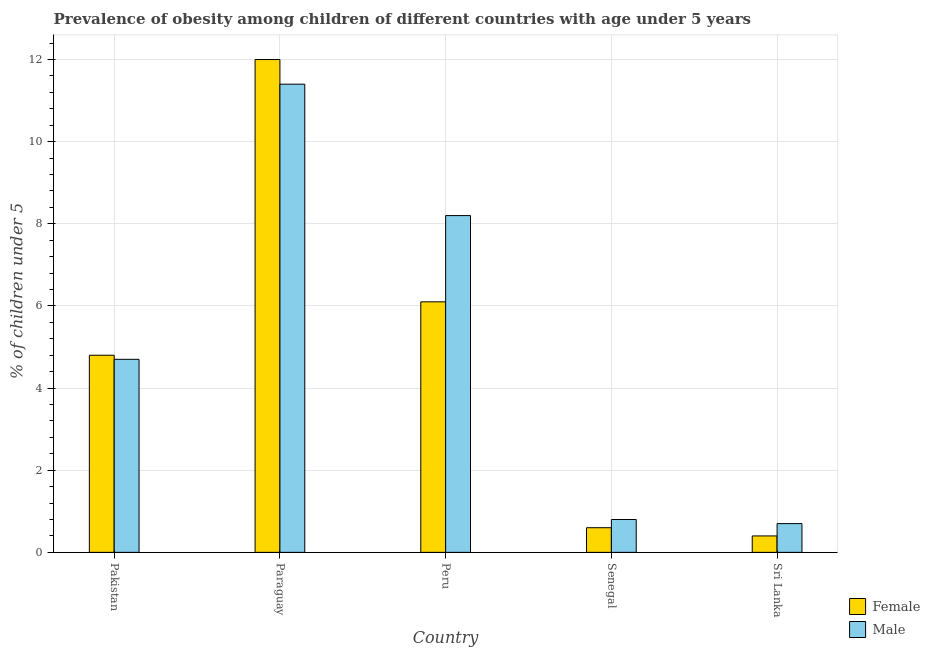How many different coloured bars are there?
Your answer should be compact. 2. How many groups of bars are there?
Offer a very short reply. 5. Are the number of bars on each tick of the X-axis equal?
Ensure brevity in your answer.  Yes. How many bars are there on the 4th tick from the left?
Ensure brevity in your answer.  2. How many bars are there on the 4th tick from the right?
Keep it short and to the point. 2. What is the label of the 3rd group of bars from the left?
Give a very brief answer. Peru. What is the percentage of obese female children in Senegal?
Provide a short and direct response. 0.6. Across all countries, what is the maximum percentage of obese male children?
Your response must be concise. 11.4. Across all countries, what is the minimum percentage of obese male children?
Offer a terse response. 0.7. In which country was the percentage of obese female children maximum?
Your answer should be compact. Paraguay. In which country was the percentage of obese male children minimum?
Offer a terse response. Sri Lanka. What is the total percentage of obese female children in the graph?
Keep it short and to the point. 23.9. What is the difference between the percentage of obese female children in Pakistan and that in Sri Lanka?
Offer a terse response. 4.4. What is the difference between the percentage of obese female children in Senegal and the percentage of obese male children in Pakistan?
Provide a short and direct response. -4.1. What is the average percentage of obese male children per country?
Offer a very short reply. 5.16. What is the difference between the percentage of obese female children and percentage of obese male children in Paraguay?
Provide a succinct answer. 0.6. In how many countries, is the percentage of obese female children greater than 0.8 %?
Your response must be concise. 3. What is the ratio of the percentage of obese female children in Paraguay to that in Peru?
Offer a terse response. 1.97. What is the difference between the highest and the second highest percentage of obese male children?
Provide a succinct answer. 3.2. What is the difference between the highest and the lowest percentage of obese male children?
Provide a succinct answer. 10.7. In how many countries, is the percentage of obese female children greater than the average percentage of obese female children taken over all countries?
Your answer should be compact. 3. Is the sum of the percentage of obese female children in Peru and Senegal greater than the maximum percentage of obese male children across all countries?
Provide a short and direct response. No. What does the 1st bar from the right in Senegal represents?
Provide a succinct answer. Male. Are all the bars in the graph horizontal?
Give a very brief answer. No. What is the difference between two consecutive major ticks on the Y-axis?
Make the answer very short. 2. Does the graph contain any zero values?
Your answer should be very brief. No. Where does the legend appear in the graph?
Your answer should be very brief. Bottom right. How many legend labels are there?
Give a very brief answer. 2. How are the legend labels stacked?
Make the answer very short. Vertical. What is the title of the graph?
Keep it short and to the point. Prevalence of obesity among children of different countries with age under 5 years. What is the label or title of the X-axis?
Offer a terse response. Country. What is the label or title of the Y-axis?
Provide a succinct answer.  % of children under 5. What is the  % of children under 5 of Female in Pakistan?
Give a very brief answer. 4.8. What is the  % of children under 5 of Male in Pakistan?
Your answer should be compact. 4.7. What is the  % of children under 5 of Male in Paraguay?
Provide a short and direct response. 11.4. What is the  % of children under 5 of Female in Peru?
Your response must be concise. 6.1. What is the  % of children under 5 in Male in Peru?
Keep it short and to the point. 8.2. What is the  % of children under 5 in Female in Senegal?
Provide a short and direct response. 0.6. What is the  % of children under 5 in Male in Senegal?
Your response must be concise. 0.8. What is the  % of children under 5 of Female in Sri Lanka?
Offer a very short reply. 0.4. What is the  % of children under 5 of Male in Sri Lanka?
Give a very brief answer. 0.7. Across all countries, what is the maximum  % of children under 5 of Male?
Provide a succinct answer. 11.4. Across all countries, what is the minimum  % of children under 5 of Female?
Your answer should be compact. 0.4. Across all countries, what is the minimum  % of children under 5 in Male?
Keep it short and to the point. 0.7. What is the total  % of children under 5 in Female in the graph?
Make the answer very short. 23.9. What is the total  % of children under 5 of Male in the graph?
Your answer should be compact. 25.8. What is the difference between the  % of children under 5 in Female in Pakistan and that in Senegal?
Provide a short and direct response. 4.2. What is the difference between the  % of children under 5 in Male in Pakistan and that in Senegal?
Your answer should be compact. 3.9. What is the difference between the  % of children under 5 of Female in Pakistan and that in Sri Lanka?
Your answer should be compact. 4.4. What is the difference between the  % of children under 5 in Male in Pakistan and that in Sri Lanka?
Your answer should be compact. 4. What is the difference between the  % of children under 5 in Male in Paraguay and that in Peru?
Keep it short and to the point. 3.2. What is the difference between the  % of children under 5 in Male in Peru and that in Senegal?
Keep it short and to the point. 7.4. What is the difference between the  % of children under 5 of Male in Senegal and that in Sri Lanka?
Provide a succinct answer. 0.1. What is the difference between the  % of children under 5 of Female in Pakistan and the  % of children under 5 of Male in Peru?
Provide a succinct answer. -3.4. What is the difference between the  % of children under 5 in Female in Pakistan and the  % of children under 5 in Male in Sri Lanka?
Your response must be concise. 4.1. What is the difference between the  % of children under 5 in Female in Paraguay and the  % of children under 5 in Male in Peru?
Ensure brevity in your answer.  3.8. What is the difference between the  % of children under 5 of Female in Paraguay and the  % of children under 5 of Male in Senegal?
Your answer should be very brief. 11.2. What is the difference between the  % of children under 5 in Female in Senegal and the  % of children under 5 in Male in Sri Lanka?
Keep it short and to the point. -0.1. What is the average  % of children under 5 of Female per country?
Your response must be concise. 4.78. What is the average  % of children under 5 of Male per country?
Offer a terse response. 5.16. What is the difference between the  % of children under 5 in Female and  % of children under 5 in Male in Senegal?
Provide a short and direct response. -0.2. What is the ratio of the  % of children under 5 of Female in Pakistan to that in Paraguay?
Give a very brief answer. 0.4. What is the ratio of the  % of children under 5 of Male in Pakistan to that in Paraguay?
Provide a succinct answer. 0.41. What is the ratio of the  % of children under 5 of Female in Pakistan to that in Peru?
Keep it short and to the point. 0.79. What is the ratio of the  % of children under 5 of Male in Pakistan to that in Peru?
Make the answer very short. 0.57. What is the ratio of the  % of children under 5 in Male in Pakistan to that in Senegal?
Your answer should be very brief. 5.88. What is the ratio of the  % of children under 5 in Male in Pakistan to that in Sri Lanka?
Provide a short and direct response. 6.71. What is the ratio of the  % of children under 5 of Female in Paraguay to that in Peru?
Your answer should be compact. 1.97. What is the ratio of the  % of children under 5 in Male in Paraguay to that in Peru?
Make the answer very short. 1.39. What is the ratio of the  % of children under 5 of Female in Paraguay to that in Senegal?
Your answer should be very brief. 20. What is the ratio of the  % of children under 5 of Male in Paraguay to that in Senegal?
Provide a succinct answer. 14.25. What is the ratio of the  % of children under 5 of Female in Paraguay to that in Sri Lanka?
Your response must be concise. 30. What is the ratio of the  % of children under 5 in Male in Paraguay to that in Sri Lanka?
Your response must be concise. 16.29. What is the ratio of the  % of children under 5 in Female in Peru to that in Senegal?
Your answer should be compact. 10.17. What is the ratio of the  % of children under 5 of Male in Peru to that in Senegal?
Offer a very short reply. 10.25. What is the ratio of the  % of children under 5 of Female in Peru to that in Sri Lanka?
Offer a very short reply. 15.25. What is the ratio of the  % of children under 5 in Male in Peru to that in Sri Lanka?
Your response must be concise. 11.71. What is the ratio of the  % of children under 5 in Female in Senegal to that in Sri Lanka?
Your answer should be compact. 1.5. What is the ratio of the  % of children under 5 in Male in Senegal to that in Sri Lanka?
Offer a very short reply. 1.14. 